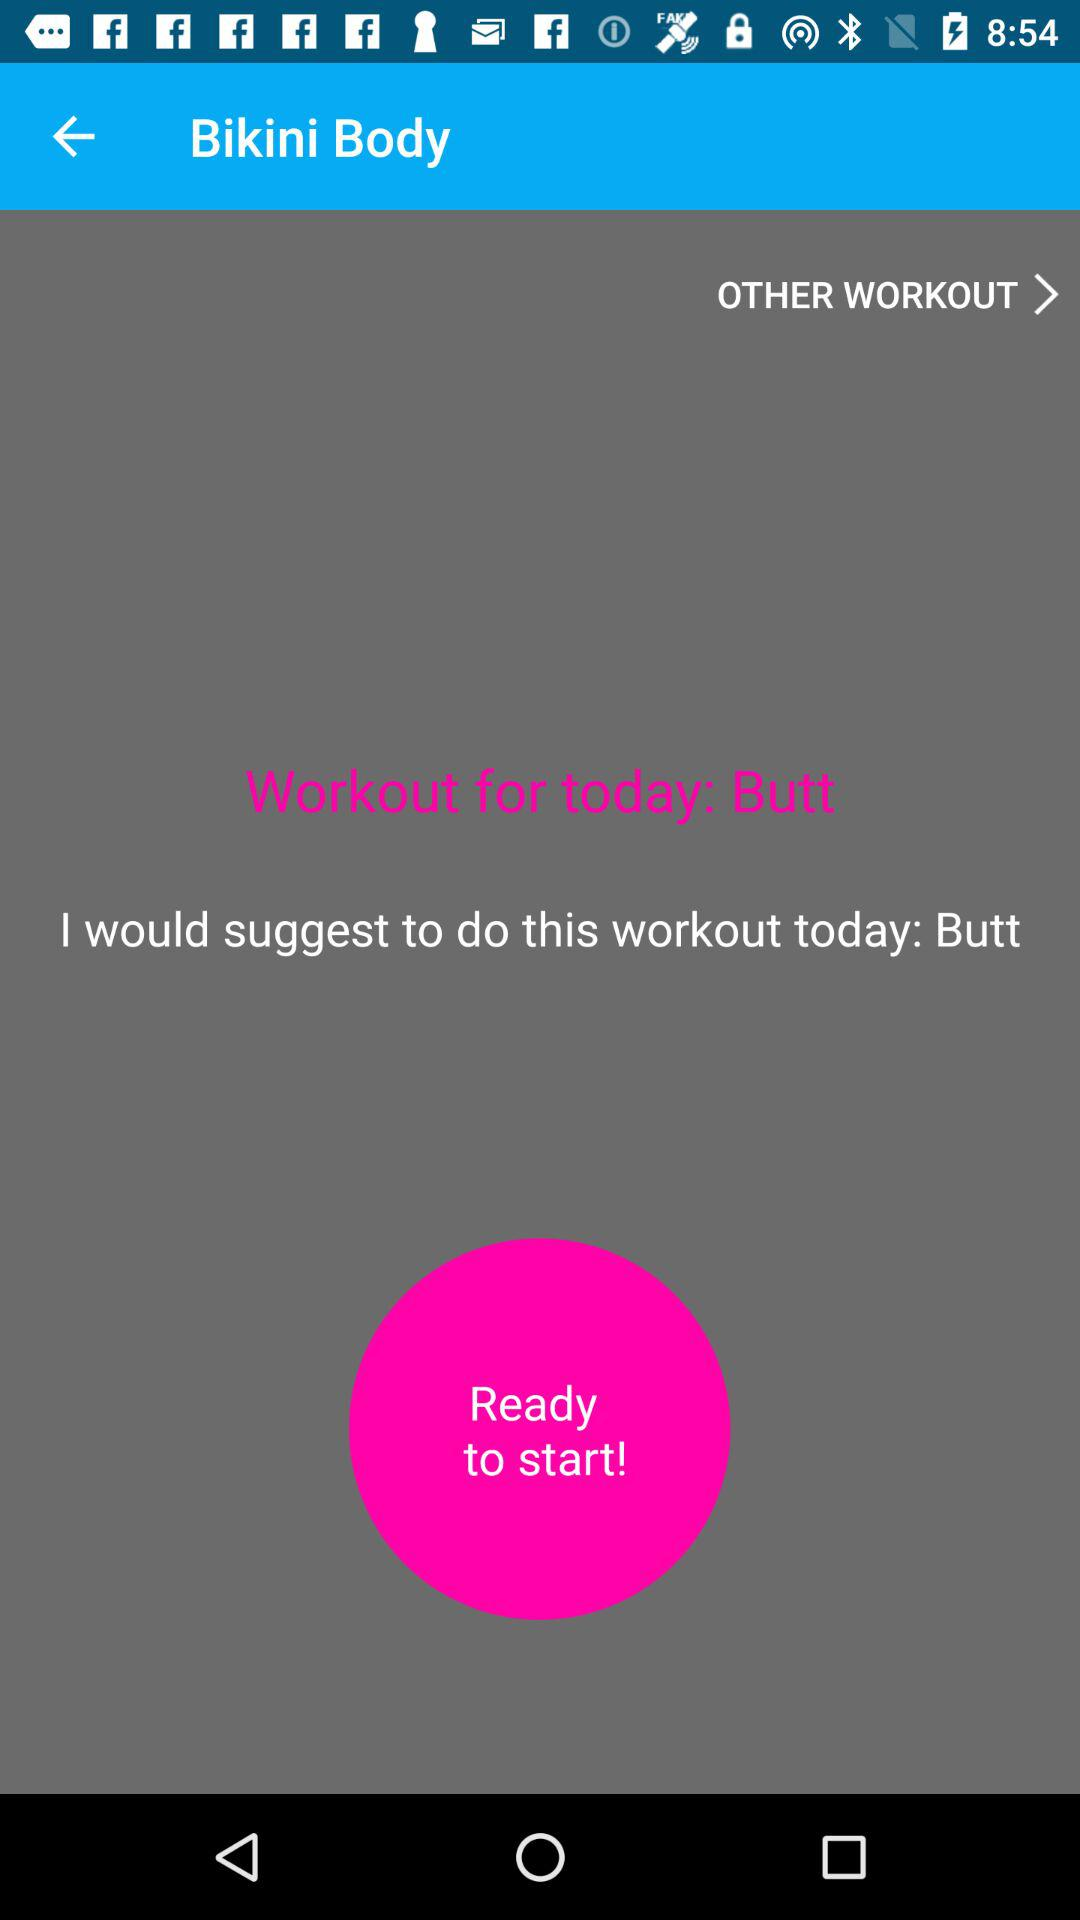What part of the body is today's workout for? Today's workout is for the "Butt" part of the body. 